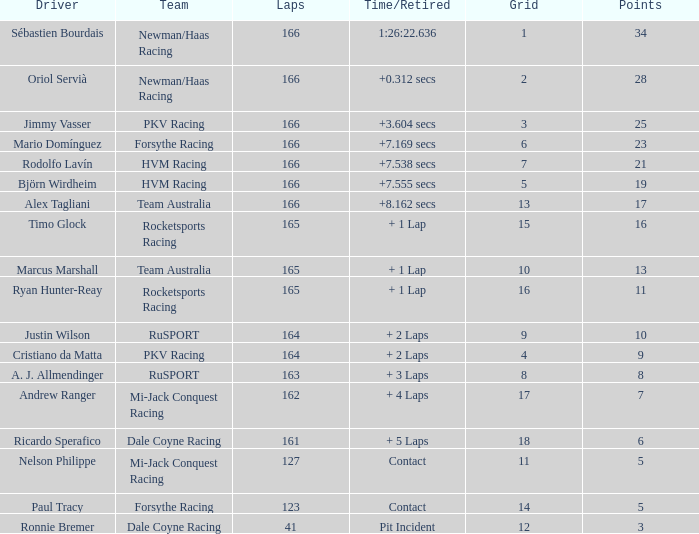What is the maximum points when the grid is smaller than 13 and the time/retired is + 21.0. 